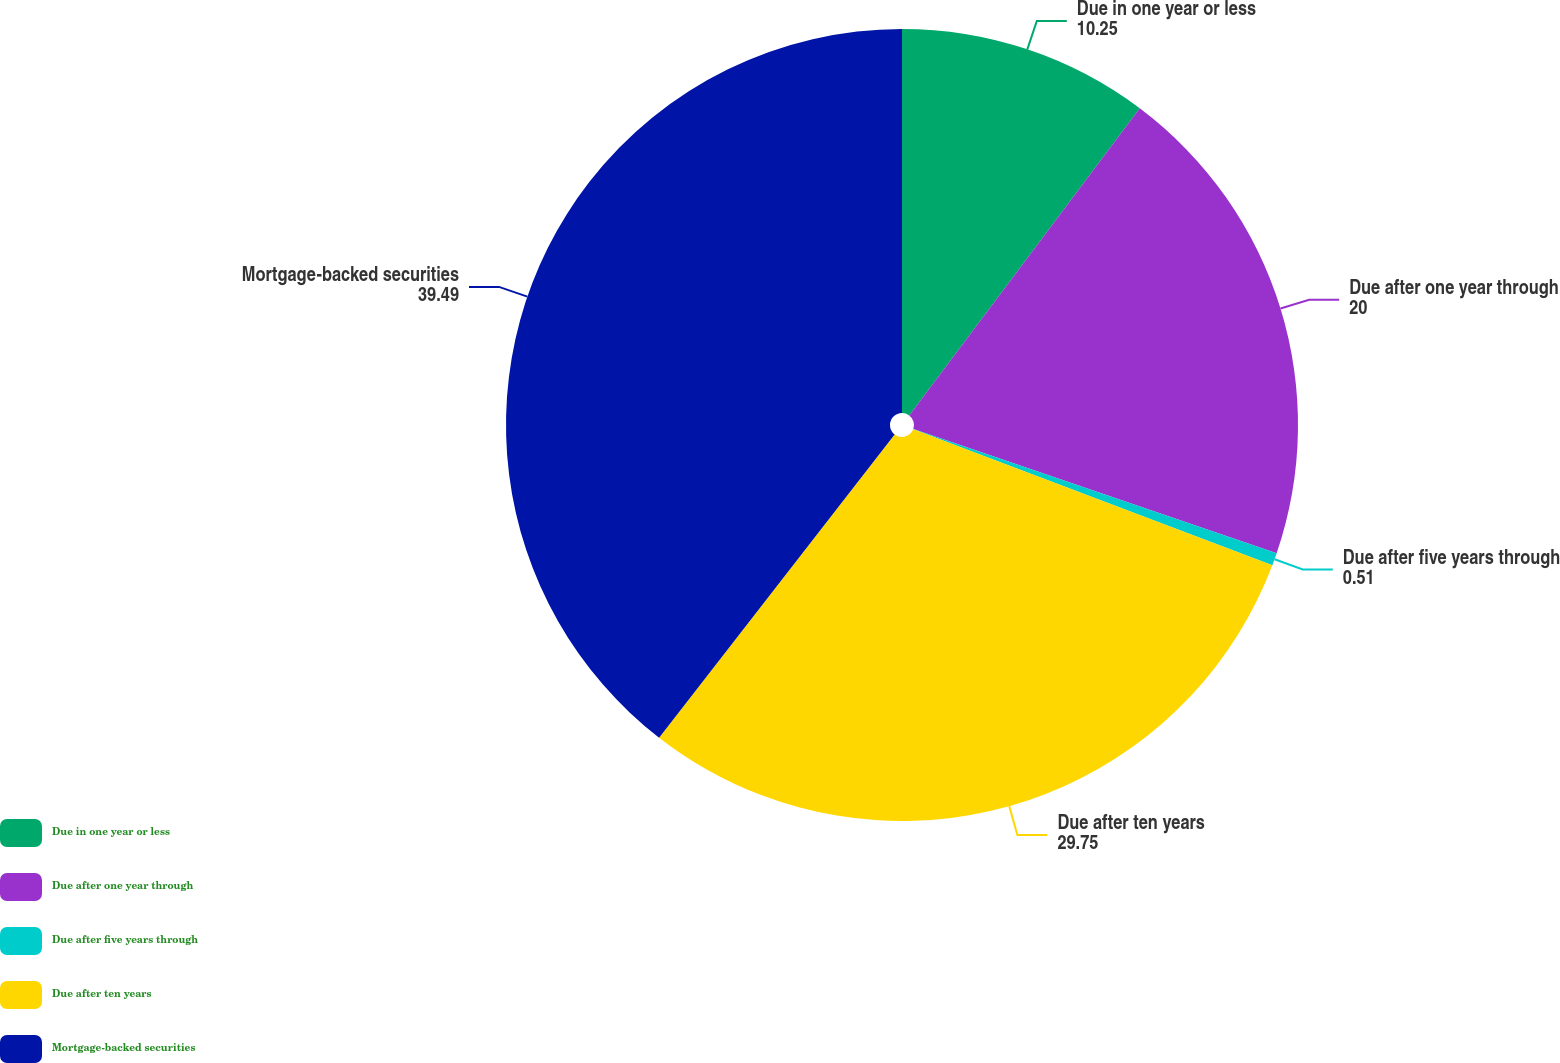Convert chart to OTSL. <chart><loc_0><loc_0><loc_500><loc_500><pie_chart><fcel>Due in one year or less<fcel>Due after one year through<fcel>Due after five years through<fcel>Due after ten years<fcel>Mortgage-backed securities<nl><fcel>10.25%<fcel>20.0%<fcel>0.51%<fcel>29.75%<fcel>39.49%<nl></chart> 